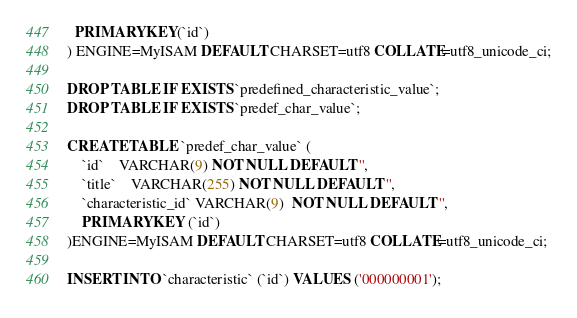Convert code to text. <code><loc_0><loc_0><loc_500><loc_500><_SQL_>  PRIMARY KEY(`id`)
) ENGINE=MyISAM DEFAULT CHARSET=utf8 COLLATE=utf8_unicode_ci;

DROP TABLE IF EXISTS `predefined_characteristic_value`;
DROP TABLE IF EXISTS `predef_char_value`;

CREATE TABLE `predef_char_value` (
	`id`	VARCHAR(9) NOT NULL DEFAULT '',
	`title`	VARCHAR(255) NOT NULL DEFAULT '',
	`characteristic_id` VARCHAR(9)  NOT NULL DEFAULT '',
	PRIMARY KEY (`id`)
)ENGINE=MyISAM DEFAULT CHARSET=utf8 COLLATE=utf8_unicode_ci;

INSERT INTO `characteristic` (`id`) VALUES ('000000001');
</code> 